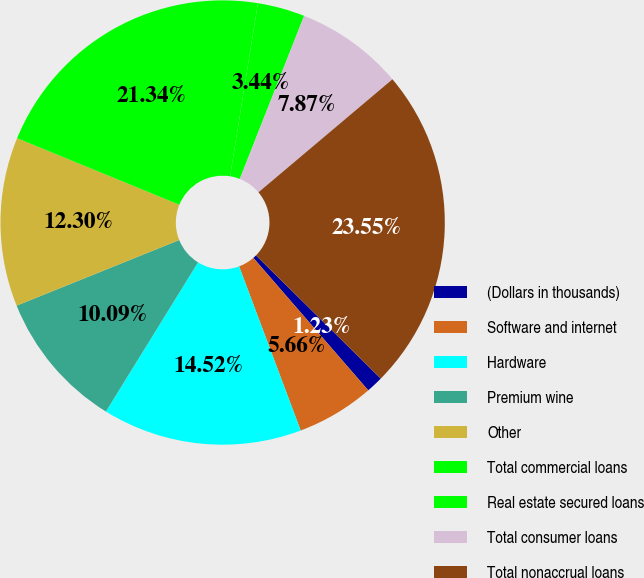Convert chart to OTSL. <chart><loc_0><loc_0><loc_500><loc_500><pie_chart><fcel>(Dollars in thousands)<fcel>Software and internet<fcel>Hardware<fcel>Premium wine<fcel>Other<fcel>Total commercial loans<fcel>Real estate secured loans<fcel>Total consumer loans<fcel>Total nonaccrual loans<nl><fcel>1.23%<fcel>5.66%<fcel>14.52%<fcel>10.09%<fcel>12.3%<fcel>21.34%<fcel>3.44%<fcel>7.87%<fcel>23.55%<nl></chart> 